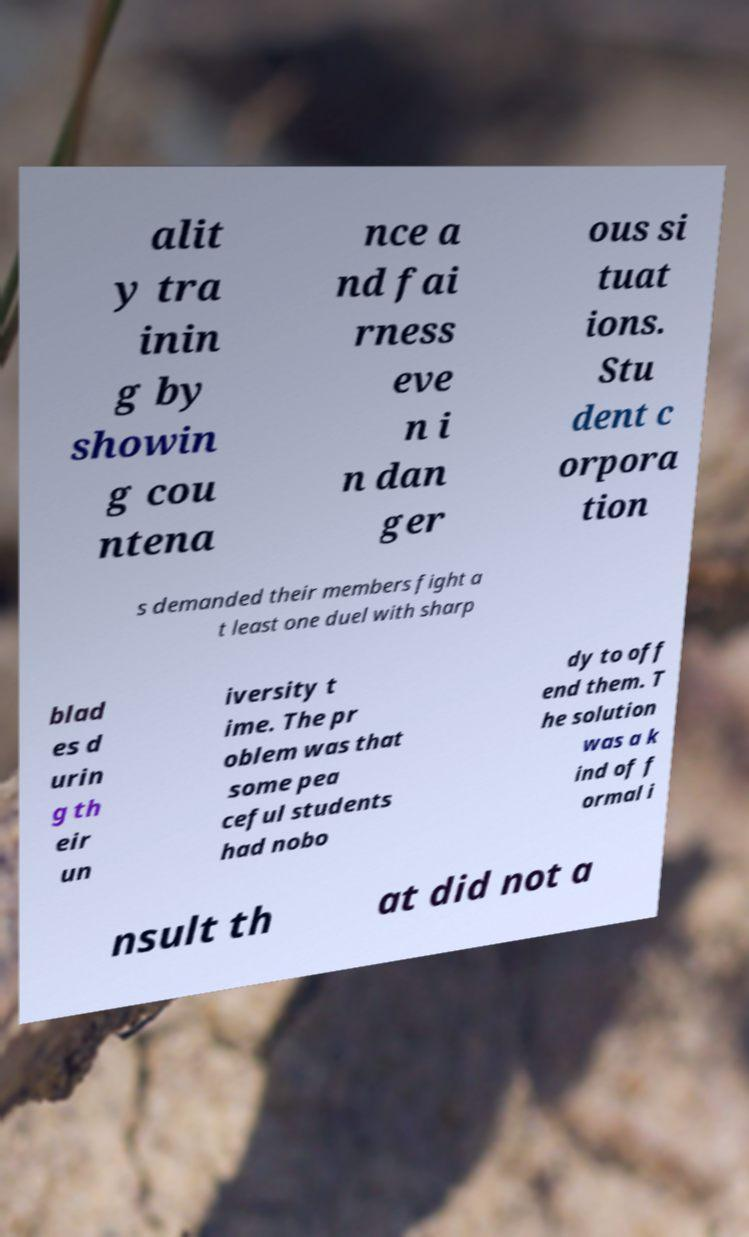I need the written content from this picture converted into text. Can you do that? alit y tra inin g by showin g cou ntena nce a nd fai rness eve n i n dan ger ous si tuat ions. Stu dent c orpora tion s demanded their members fight a t least one duel with sharp blad es d urin g th eir un iversity t ime. The pr oblem was that some pea ceful students had nobo dy to off end them. T he solution was a k ind of f ormal i nsult th at did not a 